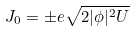<formula> <loc_0><loc_0><loc_500><loc_500>J _ { 0 } = \pm e \sqrt { 2 | \phi | ^ { 2 } U }</formula> 